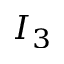<formula> <loc_0><loc_0><loc_500><loc_500>I _ { 3 }</formula> 